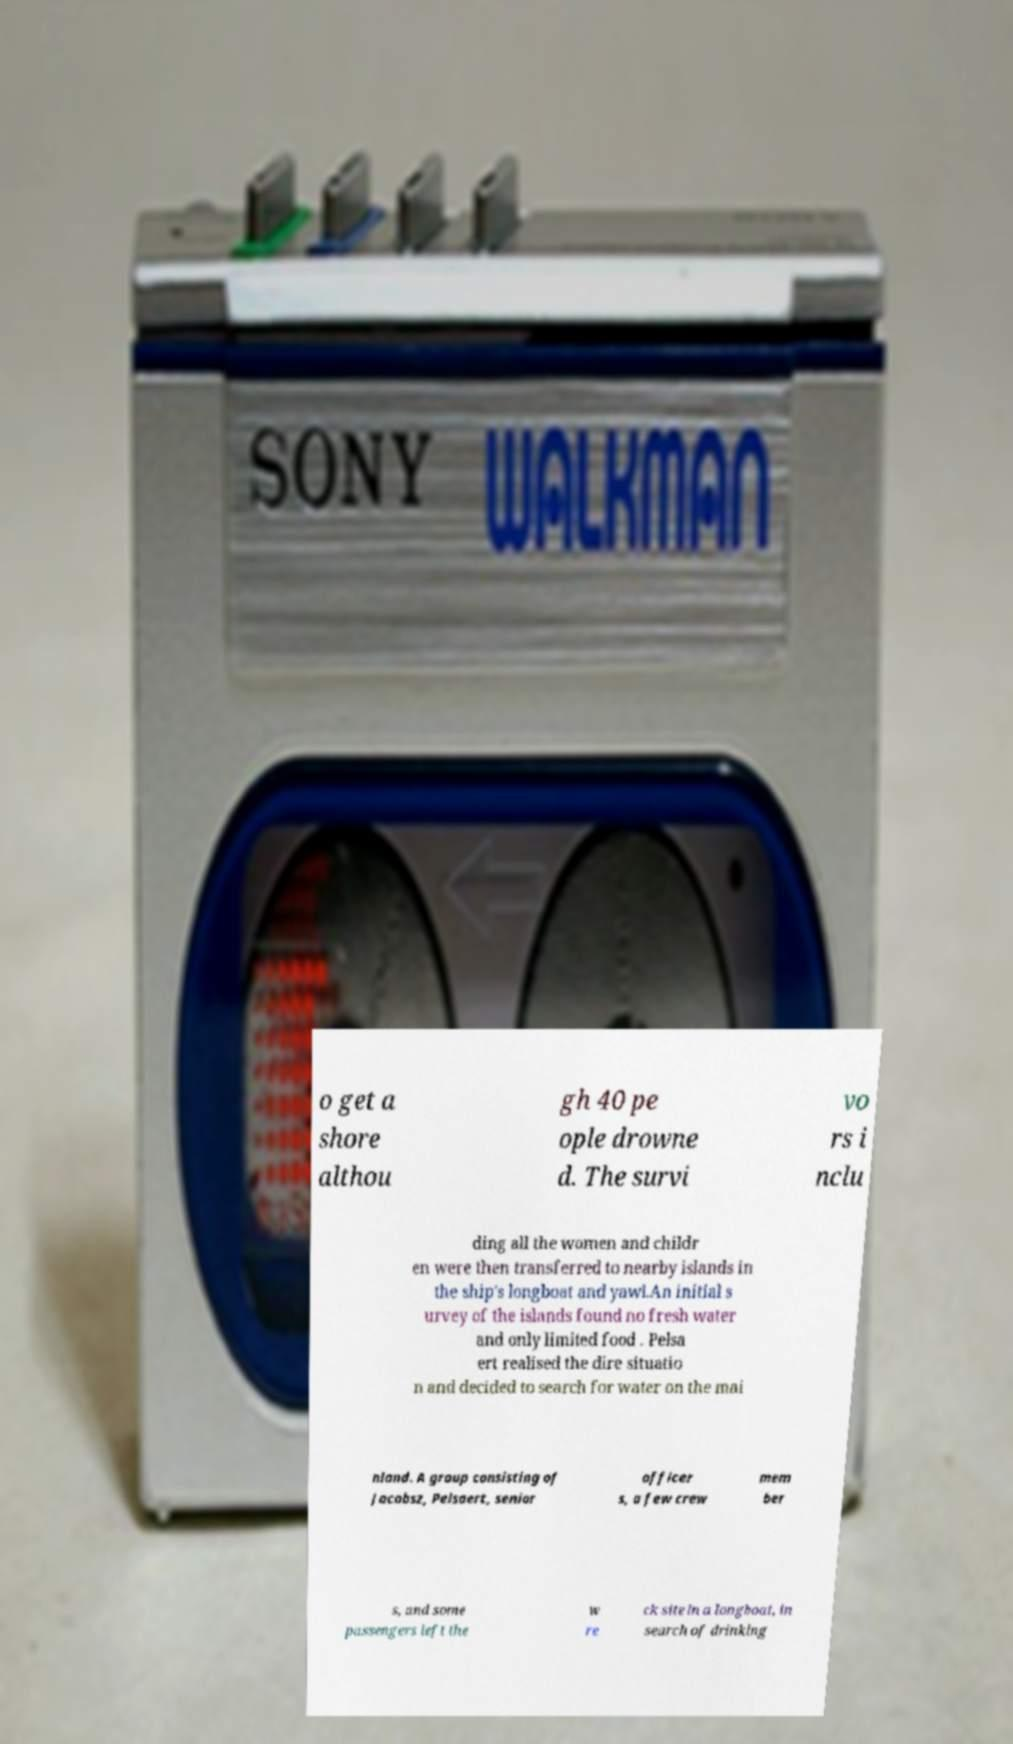Can you accurately transcribe the text from the provided image for me? o get a shore althou gh 40 pe ople drowne d. The survi vo rs i nclu ding all the women and childr en were then transferred to nearby islands in the ship's longboat and yawl.An initial s urvey of the islands found no fresh water and only limited food . Pelsa ert realised the dire situatio n and decided to search for water on the mai nland. A group consisting of Jacobsz, Pelsaert, senior officer s, a few crew mem ber s, and some passengers left the w re ck site in a longboat, in search of drinking 